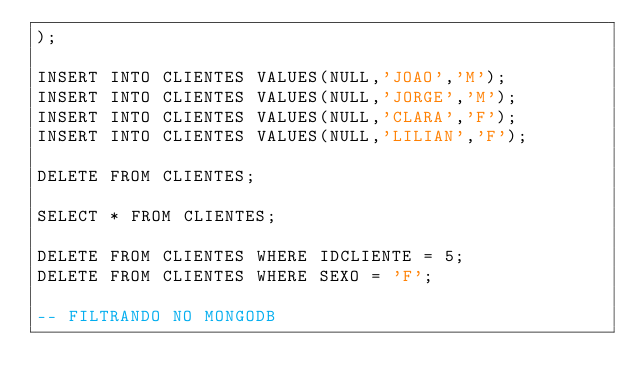<code> <loc_0><loc_0><loc_500><loc_500><_SQL_>);

INSERT INTO CLIENTES VALUES(NULL,'JOAO','M');
INSERT INTO CLIENTES VALUES(NULL,'JORGE','M');
INSERT INTO CLIENTES VALUES(NULL,'CLARA','F');
INSERT INTO CLIENTES VALUES(NULL,'LILIAN','F');

DELETE FROM CLIENTES;

SELECT * FROM CLIENTES;

DELETE FROM CLIENTES WHERE IDCLIENTE = 5;
DELETE FROM CLIENTES WHERE SEXO = 'F';

-- FILTRANDO NO MONGODB</code> 